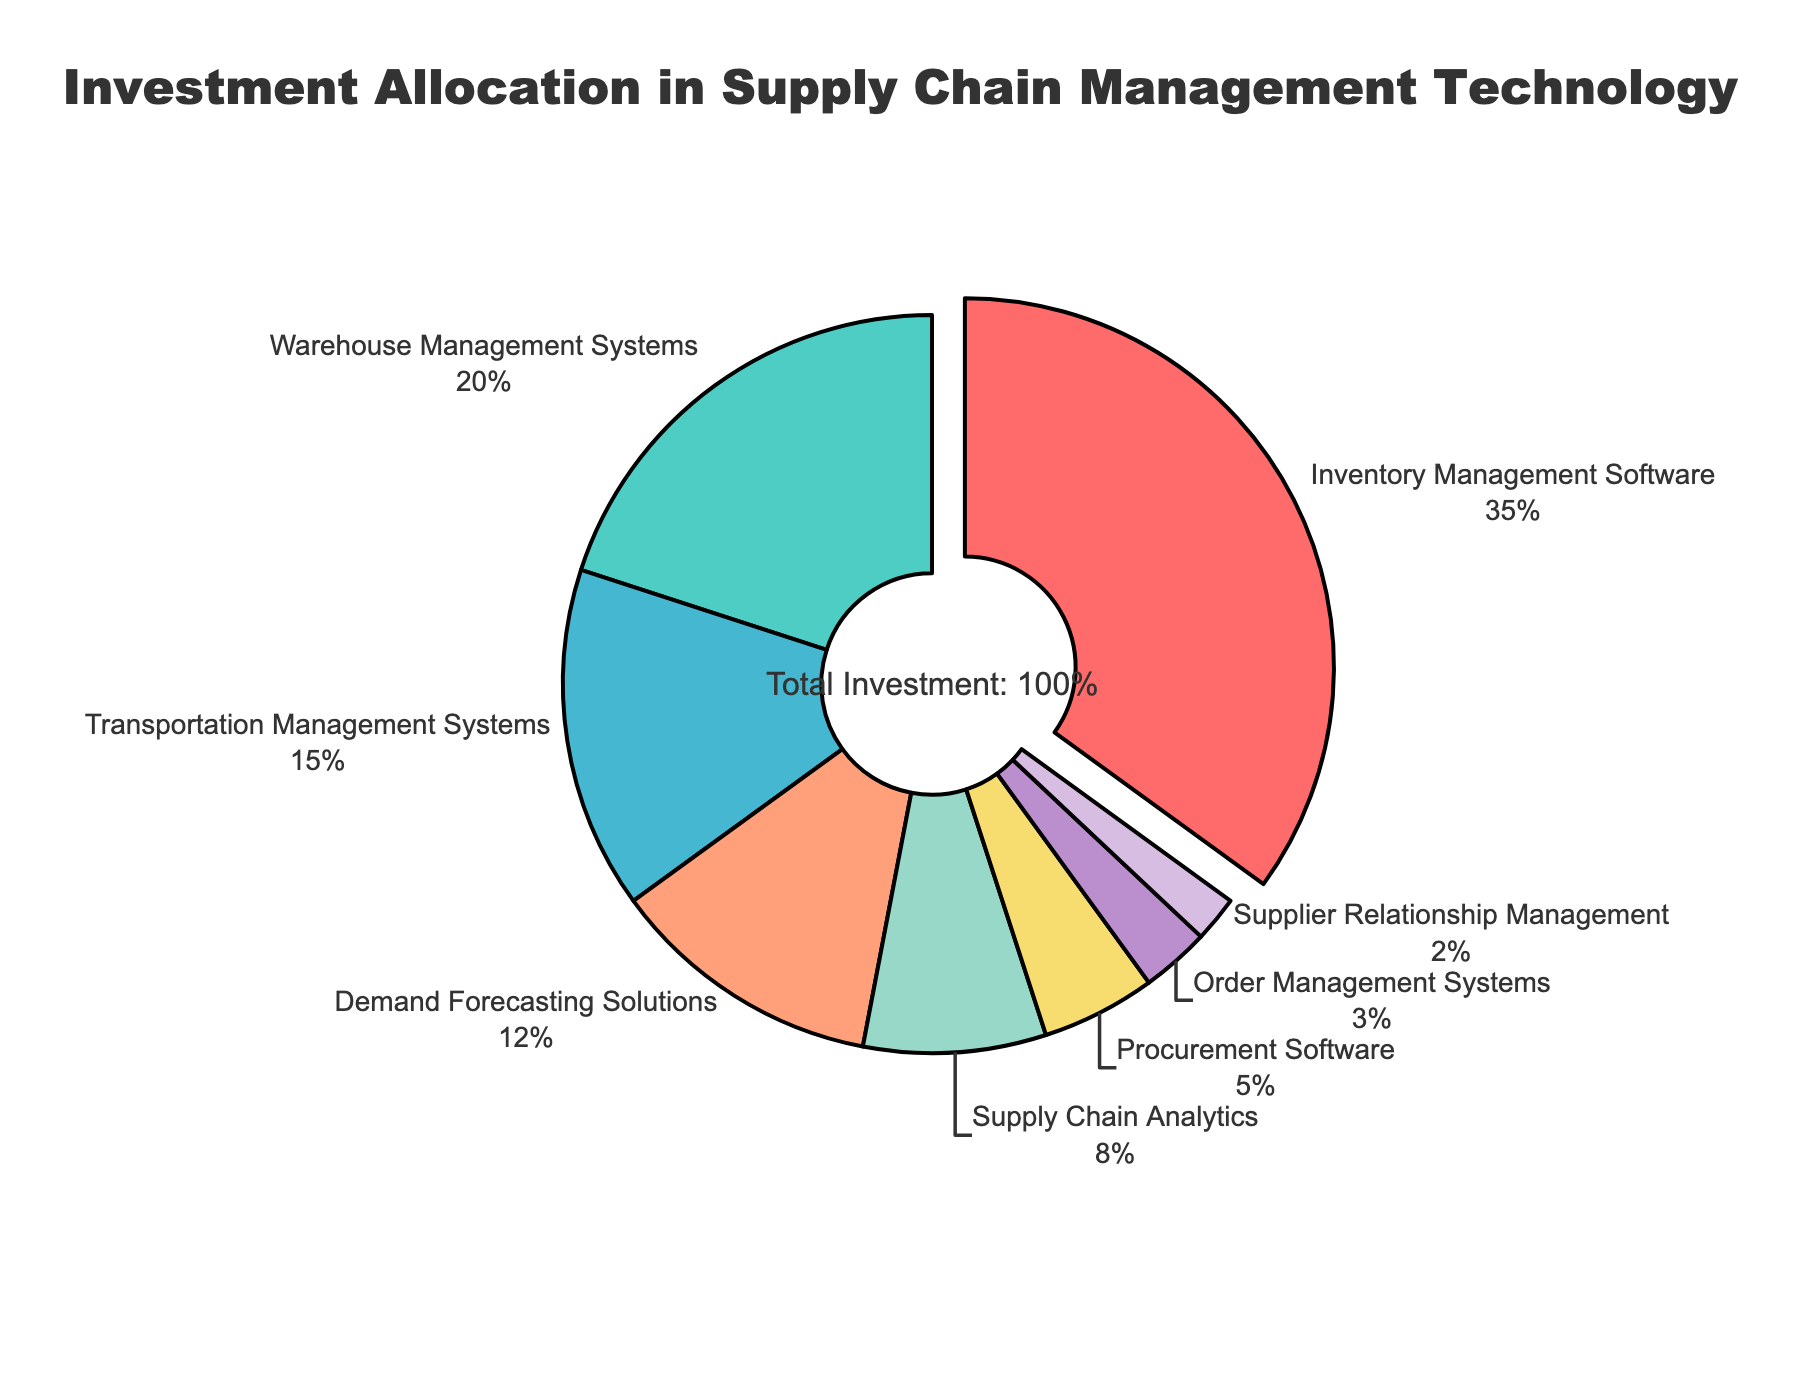What's the largest segment by investment percentage? The largest segment can be determined by identifying the section of the pie chart with the highest percentage value. Inventory Management Software has the largest slice with 35%.
Answer: Inventory Management Software What's the combined investment percentage of Warehouse Management Systems and Transportation Management Systems? Add the percentages of Warehouse Management Systems (20%) and Transportation Management Systems (15%). \(20 + 15 = 35\%\).
Answer: 35% Compare the investment percentages of Supply Chain Analytics and Procurement Software. Which one is higher and by how much? Subtract the percentage of Procurement Software (5%) from Supply Chain Analytics (8%). \(8 - 5 = 3\%\). Supply Chain Analytics has a higher investment by 3%.
Answer: Supply Chain Analytics by 3% What's the sum of the combined investment percentages for Order Management Systems, Supplier Relationship Management, and Demand Forecasting Solutions? Add the percentages of Order Management Systems (3%), Supplier Relationship Management (2%), and Demand Forecasting Solutions (12%). \(3 + 2 + 12 = 17\%\).
Answer: 17% Which segment has the smallest investment percentage and what is it? The smallest segment can be identified by looking for the slice with the smallest percentage value, which is Supplier Relationship Management at 2%.
Answer: Supplier Relationship Management What proportion of the total investment is allocated to Inventory Management Software relative to Supply Chain Analytics? Calculate the ratio by dividing the percentage of Inventory Management Software (35%) by Supply Chain Analytics (8%). \( \frac{35}{8} \approx 4.375 \).
Answer: ~4.375 times If the investment in Warehouse Management Systems were to increase by 5 percentage points, what would the new percentage be? Add 5 to the current percentage of Warehouse Management Systems (20%). \(20 + 5 = 25\%\).
Answer: 25% Which segments have an investment percentage below 10%, and what are their values? Identify segments with investment percentages below 10%. Procurement Software (5%), Order Management Systems (3%), and Supplier Relationship Management (2%) are below 10%.
Answer: Procurement Software (5%), Order Management Systems (3%), Supplier Relationship Management (2%) How much more investment does Inventory Management Software receive compared to Demand Forecasting Solutions? Subtract the percentage of Demand Forecasting Solutions (12%) from Inventory Management Software (35%). \(35 - 12 = 23\%\).
Answer: 23% 